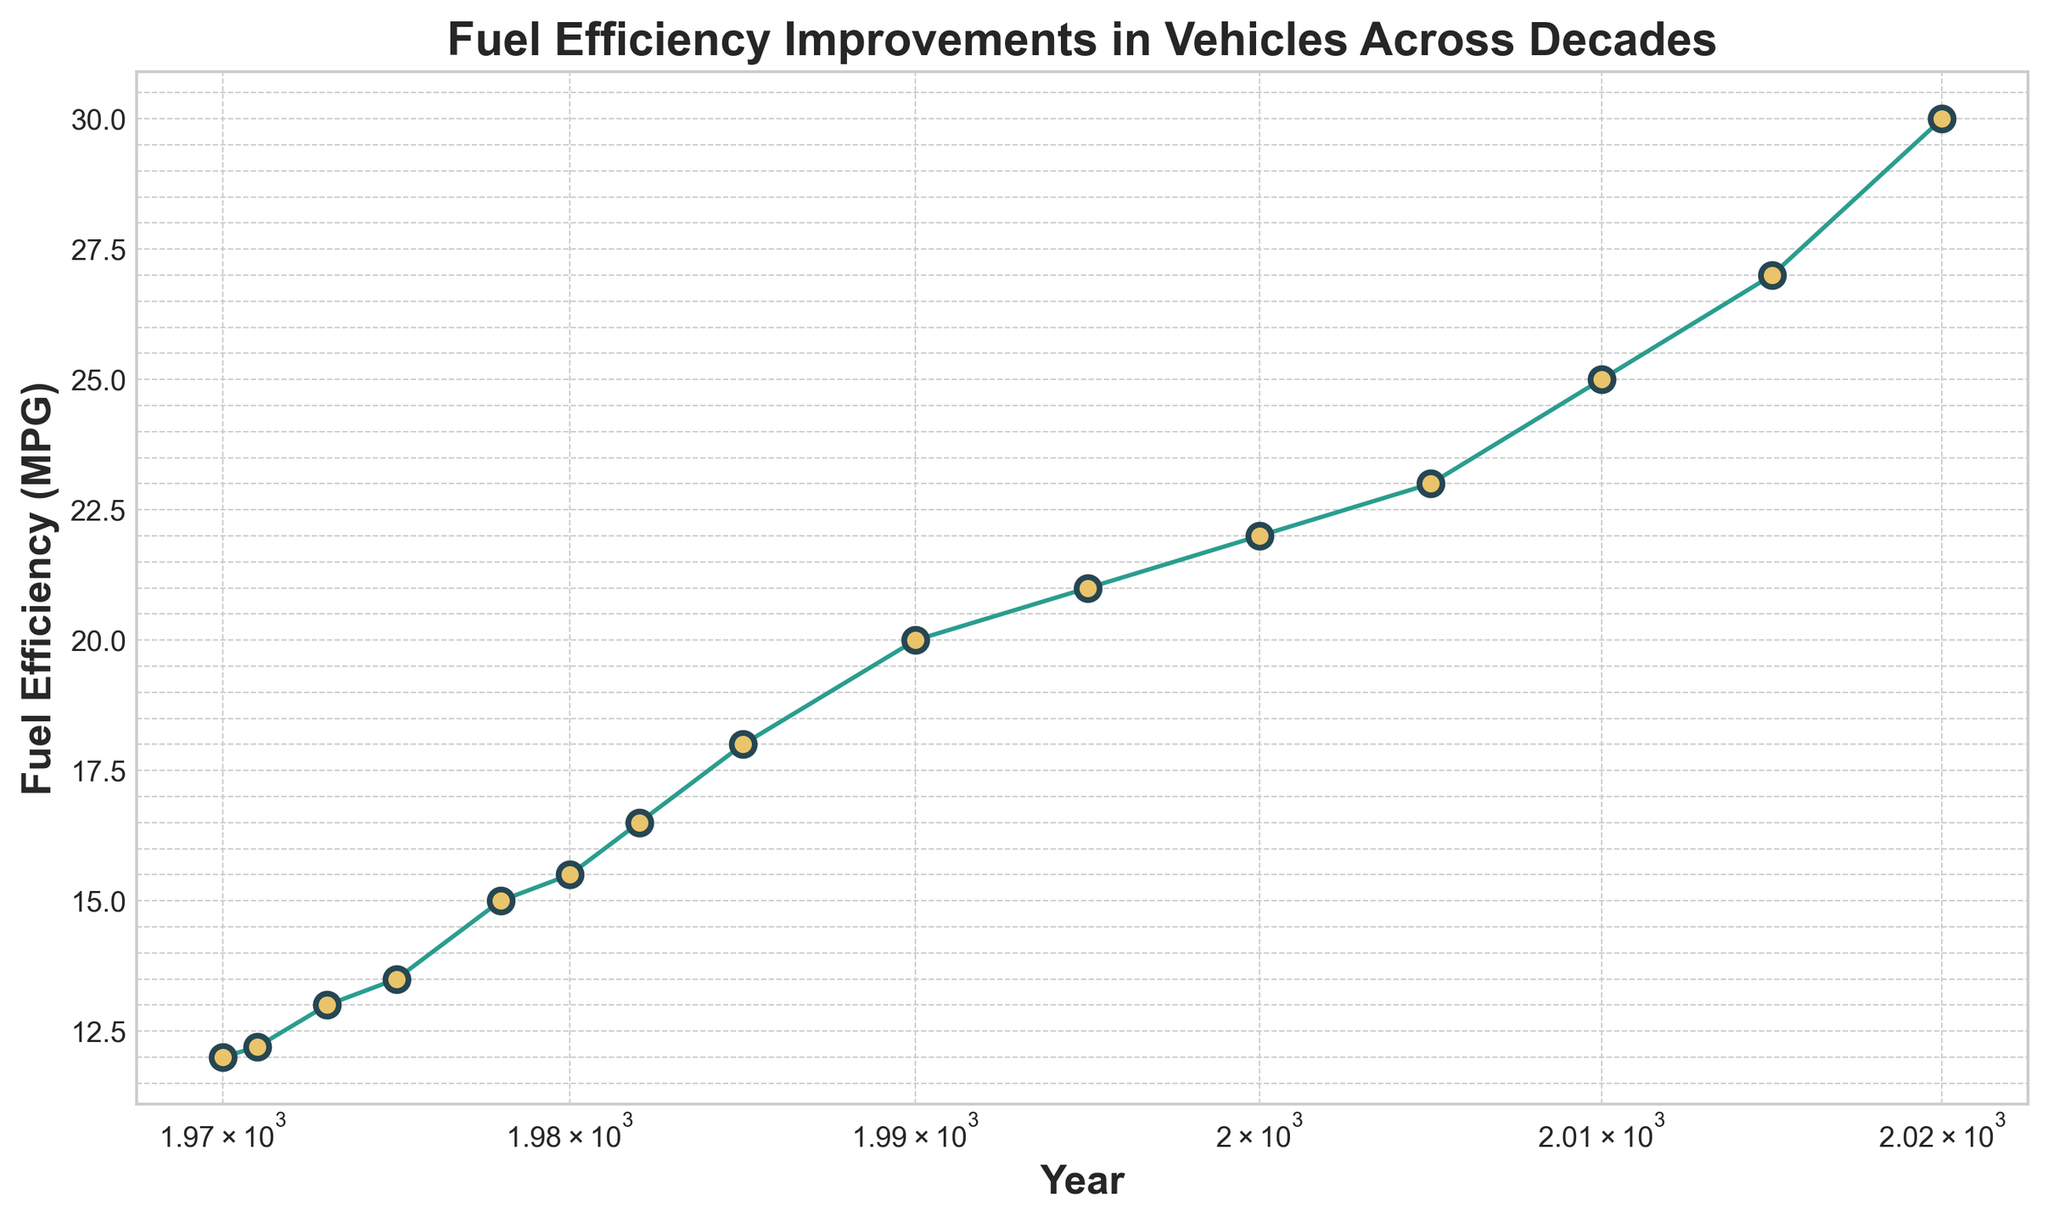What is the fuel efficiency in 1985? By looking at the x-axis for the year and finding the corresponding point on the y-axis for 1985, we see the fuel efficiency is 18 MPG.
Answer: 18 MPG How much did the fuel efficiency improve from 1970 to 2020? To find the improvement, subtract the fuel efficiency in 1970 from the fuel efficiency in 2020: 30 MPG (2020) - 12 MPG (1970) = 18 MPG.
Answer: 18 MPG During which decade did the largest improvement in fuel efficiency occur? Compare fuel efficiency increases for each decade by looking at their starting and ending points: 1970s (3 MPG), 1980s (5 MPG), 1990s (1 MPG), 2000s (3 MPG), 2010s (5 MPG). The improvements in the 1980s and 2010s are the largest, each with a 5 MPG increase.
Answer: 1980s and 2010s How does the fuel efficiency in 2010 compare to that in 2000? By comparing the points on the graph, the fuel efficiency in 2010 (25 MPG) is greater than that in 2000 (22 MPG). The difference is 25 - 22 = 3 MPG.
Answer: 3 MPG What is the average fuel efficiency in the 1990s? Calculate the average by taking the sum of the fuel efficiencies in the 1990s and dividing by the number of data points. Sum: 20 (1990) + 21 (1995) = 41; Average = 41/2 = 20.5 MPG.
Answer: 20.5 MPG Describe the color and style of the line representing fuel efficiency over the years. The line is solid, colored in green with yellow circles at each data point, having blue edges.
Answer: Solid line, green with yellow circles and blue edges Is the fuel efficiency increase linear or non-linear from 1970 to 2020? By observing the plot, the fuel efficiency increases non-linearly over time, as evident from the changing slope value between decades.
Answer: Non-linear What is the median fuel efficiency value from 1970 to 2020? Arrange the fuel efficiency values in ascending order and find the middle value: [12, 12.2, 13, 13.5, 15, 15.5, 16.5, 18, 20, 21, 22, 23, 25, 27, 30]. The median value is 18 MPG.
Answer: 18 MPG Which year shows the first significant increase in fuel efficiency compared to previous years? By examining the plot, a significant increase is visible between 1975 (13.5 MPG) and 1978 (15 MPG), marking the first notable rise in fuel efficiency.
Answer: 1978 How does the trend in fuel efficiency relate to the log scale used for the x-axis? The log scale on the x-axis indicates larger year gaps as we move to the right, showing consistent improvements in fuel efficiency over extended periods. The plot reveals a non-linear improvement pattern.
Answer: Consistent improvement over years with larger year gaps 